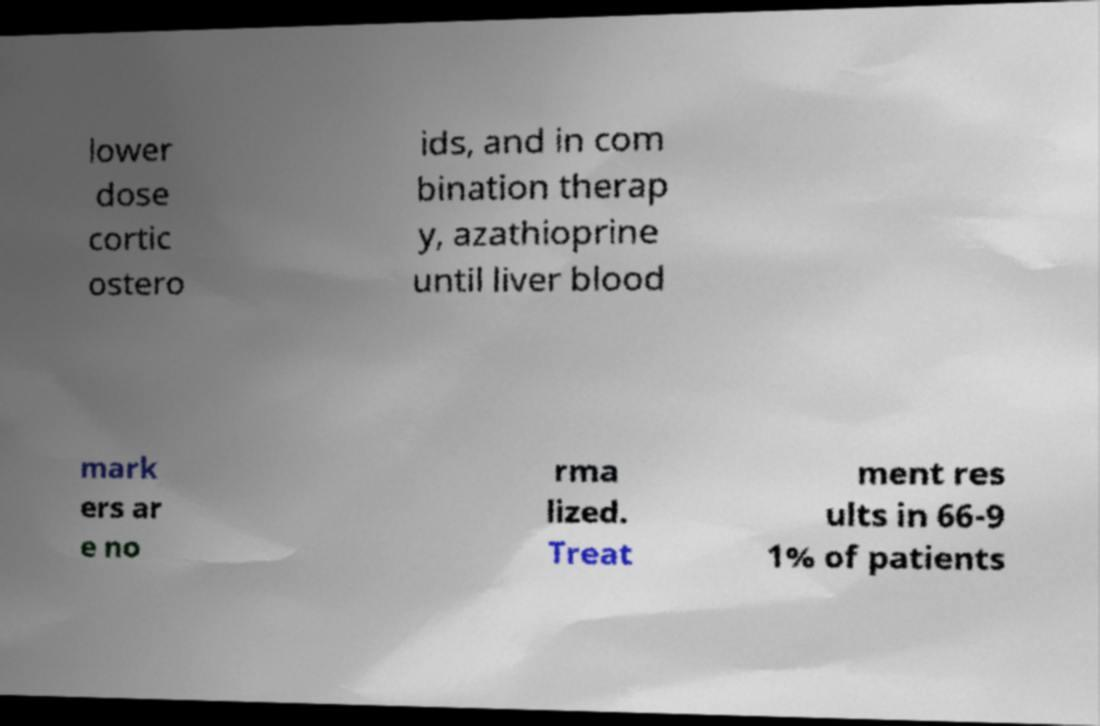There's text embedded in this image that I need extracted. Can you transcribe it verbatim? lower dose cortic ostero ids, and in com bination therap y, azathioprine until liver blood mark ers ar e no rma lized. Treat ment res ults in 66-9 1% of patients 